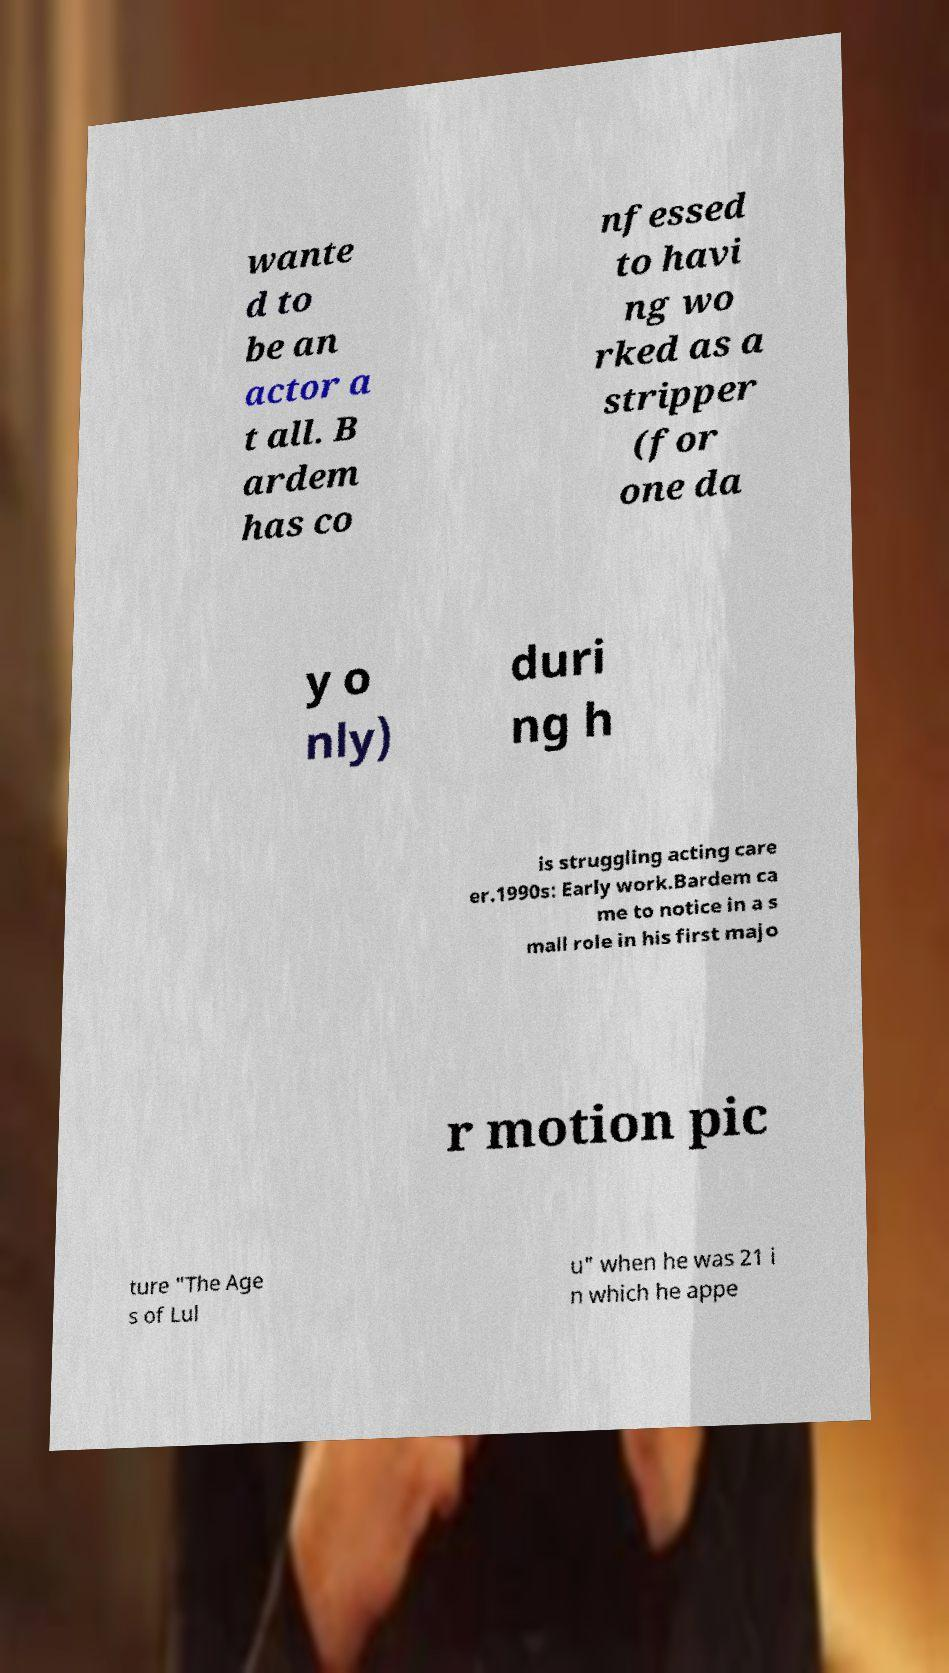There's text embedded in this image that I need extracted. Can you transcribe it verbatim? wante d to be an actor a t all. B ardem has co nfessed to havi ng wo rked as a stripper (for one da y o nly) duri ng h is struggling acting care er.1990s: Early work.Bardem ca me to notice in a s mall role in his first majo r motion pic ture "The Age s of Lul u" when he was 21 i n which he appe 